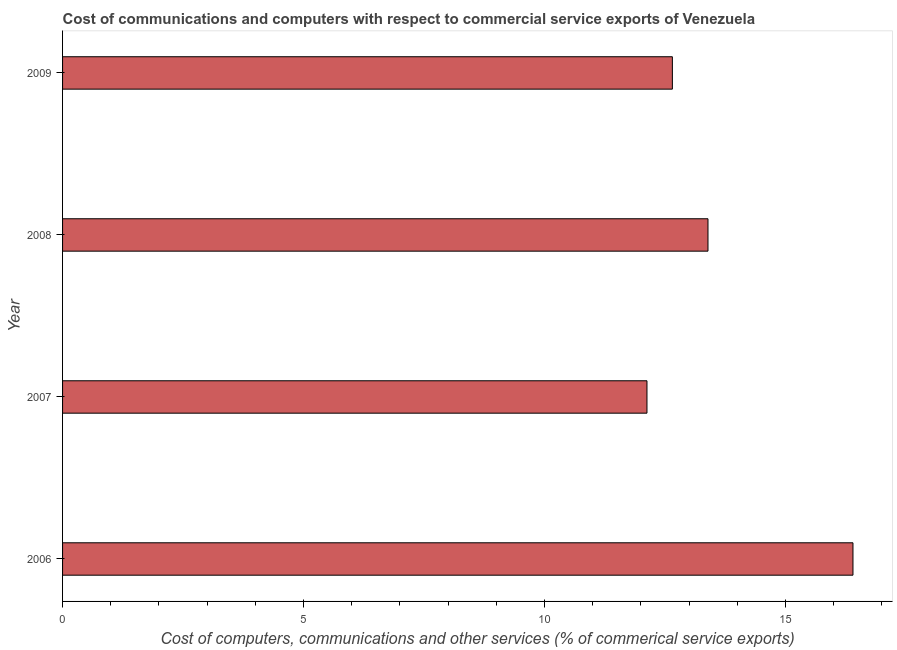Does the graph contain any zero values?
Ensure brevity in your answer.  No. Does the graph contain grids?
Offer a terse response. No. What is the title of the graph?
Make the answer very short. Cost of communications and computers with respect to commercial service exports of Venezuela. What is the label or title of the X-axis?
Offer a very short reply. Cost of computers, communications and other services (% of commerical service exports). What is the label or title of the Y-axis?
Your answer should be very brief. Year. What is the  computer and other services in 2006?
Your answer should be very brief. 16.4. Across all years, what is the maximum  computer and other services?
Provide a short and direct response. 16.4. Across all years, what is the minimum cost of communications?
Your response must be concise. 12.13. In which year was the  computer and other services maximum?
Keep it short and to the point. 2006. What is the sum of the  computer and other services?
Offer a terse response. 54.57. What is the difference between the  computer and other services in 2006 and 2009?
Offer a terse response. 3.75. What is the average  computer and other services per year?
Your answer should be compact. 13.64. What is the median  computer and other services?
Provide a succinct answer. 13.02. What is the ratio of the cost of communications in 2006 to that in 2008?
Your answer should be very brief. 1.23. Is the difference between the cost of communications in 2006 and 2008 greater than the difference between any two years?
Your answer should be compact. No. What is the difference between the highest and the second highest  computer and other services?
Make the answer very short. 3.01. What is the difference between the highest and the lowest cost of communications?
Provide a short and direct response. 4.27. How many bars are there?
Your response must be concise. 4. Are the values on the major ticks of X-axis written in scientific E-notation?
Keep it short and to the point. No. What is the Cost of computers, communications and other services (% of commerical service exports) in 2006?
Give a very brief answer. 16.4. What is the Cost of computers, communications and other services (% of commerical service exports) of 2007?
Ensure brevity in your answer.  12.13. What is the Cost of computers, communications and other services (% of commerical service exports) of 2008?
Keep it short and to the point. 13.39. What is the Cost of computers, communications and other services (% of commerical service exports) in 2009?
Your answer should be very brief. 12.65. What is the difference between the Cost of computers, communications and other services (% of commerical service exports) in 2006 and 2007?
Offer a terse response. 4.27. What is the difference between the Cost of computers, communications and other services (% of commerical service exports) in 2006 and 2008?
Make the answer very short. 3.01. What is the difference between the Cost of computers, communications and other services (% of commerical service exports) in 2006 and 2009?
Your answer should be compact. 3.75. What is the difference between the Cost of computers, communications and other services (% of commerical service exports) in 2007 and 2008?
Offer a very short reply. -1.27. What is the difference between the Cost of computers, communications and other services (% of commerical service exports) in 2007 and 2009?
Make the answer very short. -0.53. What is the difference between the Cost of computers, communications and other services (% of commerical service exports) in 2008 and 2009?
Your answer should be very brief. 0.74. What is the ratio of the Cost of computers, communications and other services (% of commerical service exports) in 2006 to that in 2007?
Your answer should be very brief. 1.35. What is the ratio of the Cost of computers, communications and other services (% of commerical service exports) in 2006 to that in 2008?
Give a very brief answer. 1.23. What is the ratio of the Cost of computers, communications and other services (% of commerical service exports) in 2006 to that in 2009?
Keep it short and to the point. 1.3. What is the ratio of the Cost of computers, communications and other services (% of commerical service exports) in 2007 to that in 2008?
Your response must be concise. 0.91. What is the ratio of the Cost of computers, communications and other services (% of commerical service exports) in 2007 to that in 2009?
Give a very brief answer. 0.96. What is the ratio of the Cost of computers, communications and other services (% of commerical service exports) in 2008 to that in 2009?
Your answer should be compact. 1.06. 